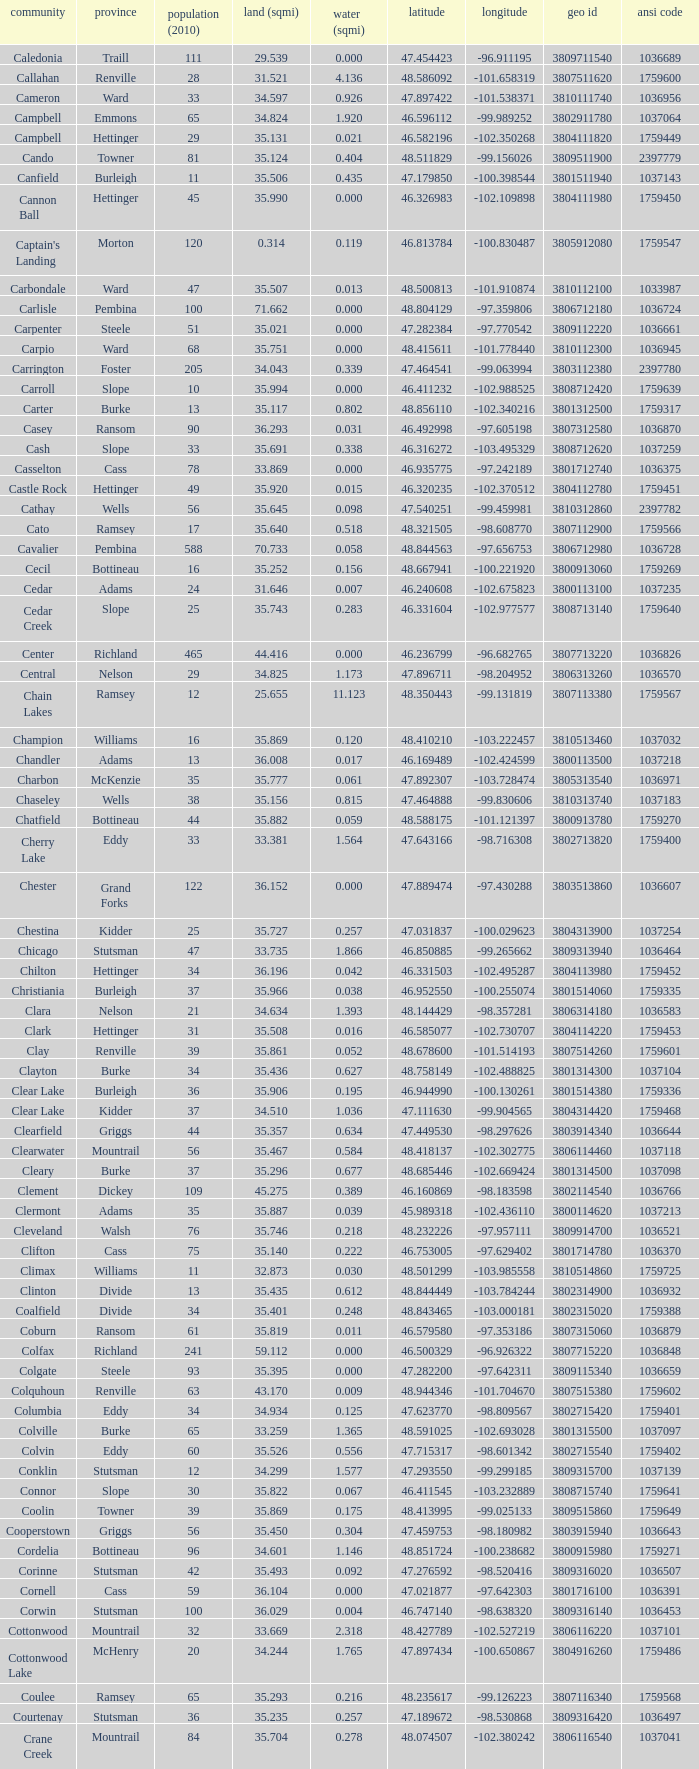What was the land area in sqmi that has a latitude of 48.763937? 35.898. 